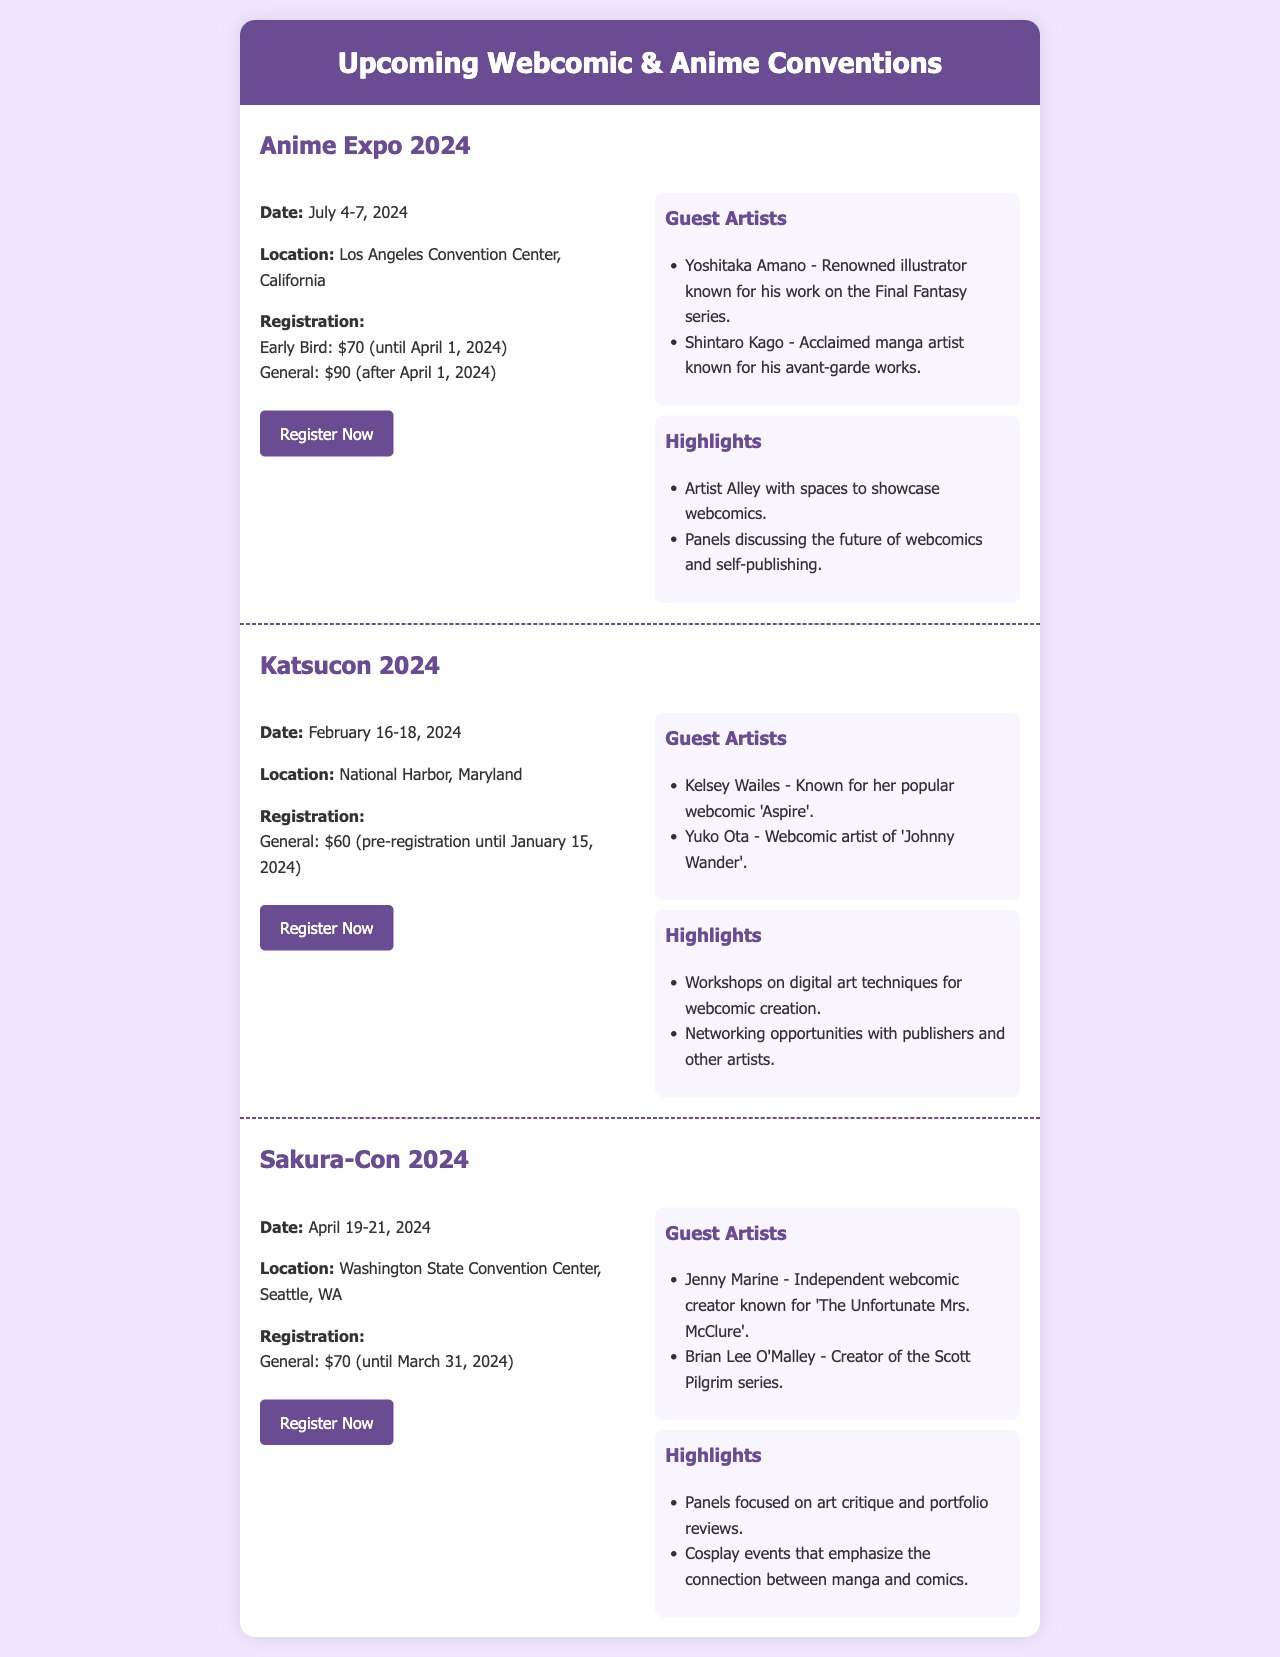What are the dates for Anime Expo 2024? The dates for Anime Expo 2024 are provided in the document, which states July 4-7, 2024.
Answer: July 4-7, 2024 Who is a guest artist at Katsucon 2024? The document lists Kelsey Wailes as a guest artist for Katsucon 2024.
Answer: Kelsey Wailes What is the registration fee for Sakura-Con 2024 until March 31, 2024? According to the document, the registration fee for Sakura-Con 2024 is $70 until March 31, 2024.
Answer: $70 When does early bird registration end for Anime Expo 2024? The document specifies that early bird registration ends on April 1, 2024.
Answer: April 1, 2024 What significant opportunity is highlighted at Katsucon 2024? The document mentions networking opportunities with publishers and other artists as a highlight for Katsucon 2024.
Answer: Networking opportunities What is one highlight for Sakura-Con 2024 related to art? The document indicates that panels focused on art critique and portfolio reviews are highlights for Sakura-Con 2024.
Answer: Art critique and portfolio reviews How many days is Katsucon 2024? Katsucon 2024 takes place over three days, from February 16-18, 2024.
Answer: Three days Which convention features Yoshitaka Amano as a guest artist? The document notes that Yoshitaka Amano is a guest artist at Anime Expo 2024.
Answer: Anime Expo 2024 